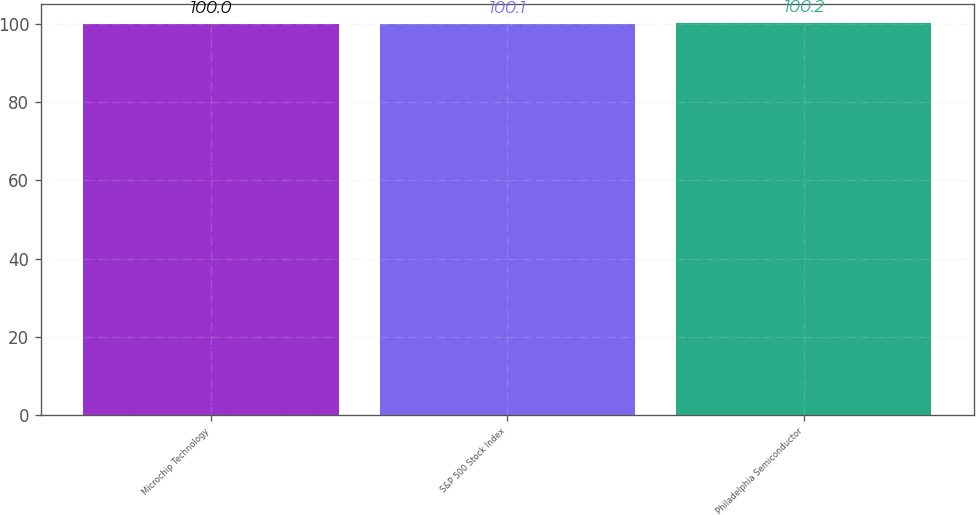Convert chart to OTSL. <chart><loc_0><loc_0><loc_500><loc_500><bar_chart><fcel>Microchip Technology<fcel>S&P 500 Stock Index<fcel>Philadelphia Semiconductor<nl><fcel>100<fcel>100.1<fcel>100.2<nl></chart> 